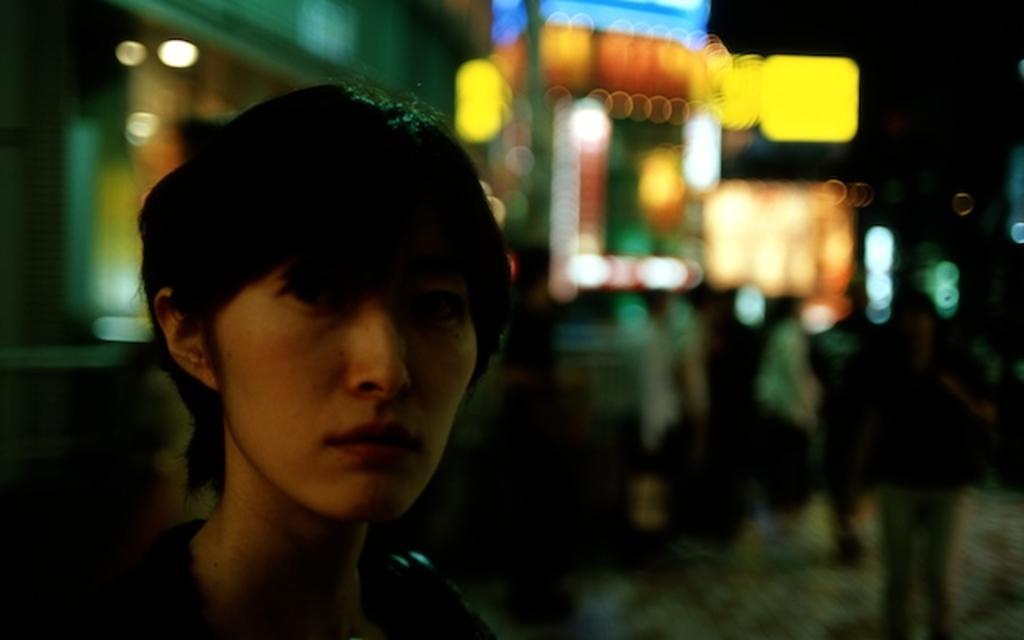Could you give a brief overview of what you see in this image? In this image there is a woman staring. 